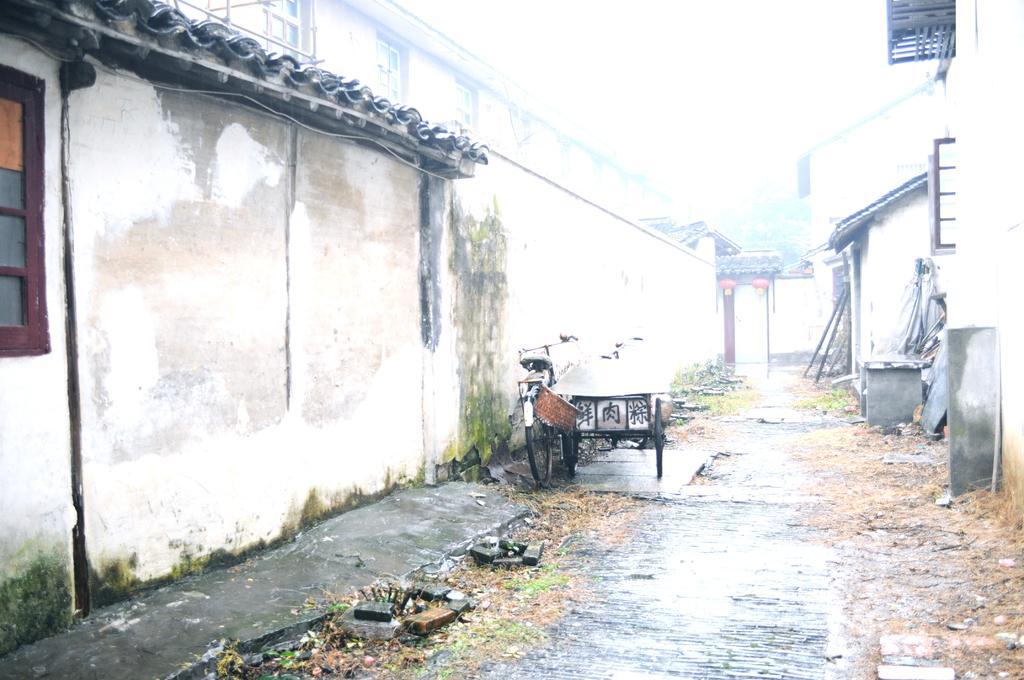Could you give a brief overview of what you see in this image? This picture consists of the wall , in front of the wall I can see a bi-cycle and cart vehicle and there is a house on the right side, at the top I can see the sky. 